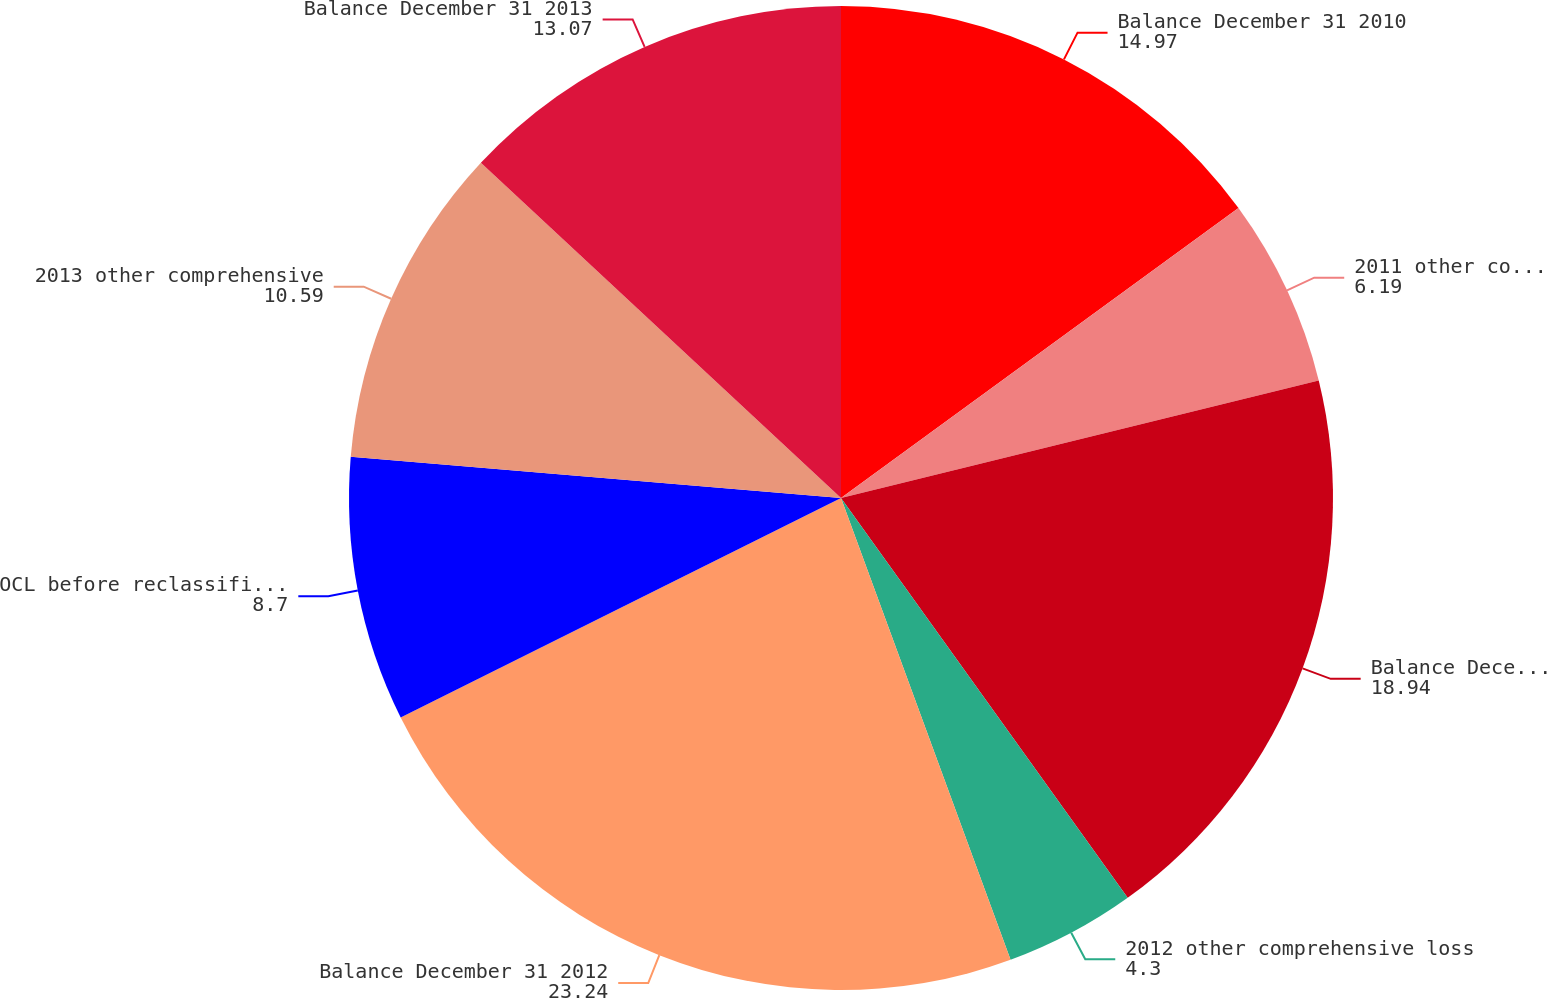Convert chart to OTSL. <chart><loc_0><loc_0><loc_500><loc_500><pie_chart><fcel>Balance December 31 2010<fcel>2011 other comprehensive loss<fcel>Balance December 31 2011<fcel>2012 other comprehensive loss<fcel>Balance December 31 2012<fcel>OCL before reclassifications<fcel>2013 other comprehensive<fcel>Balance December 31 2013<nl><fcel>14.97%<fcel>6.19%<fcel>18.94%<fcel>4.3%<fcel>23.24%<fcel>8.7%<fcel>10.59%<fcel>13.07%<nl></chart> 